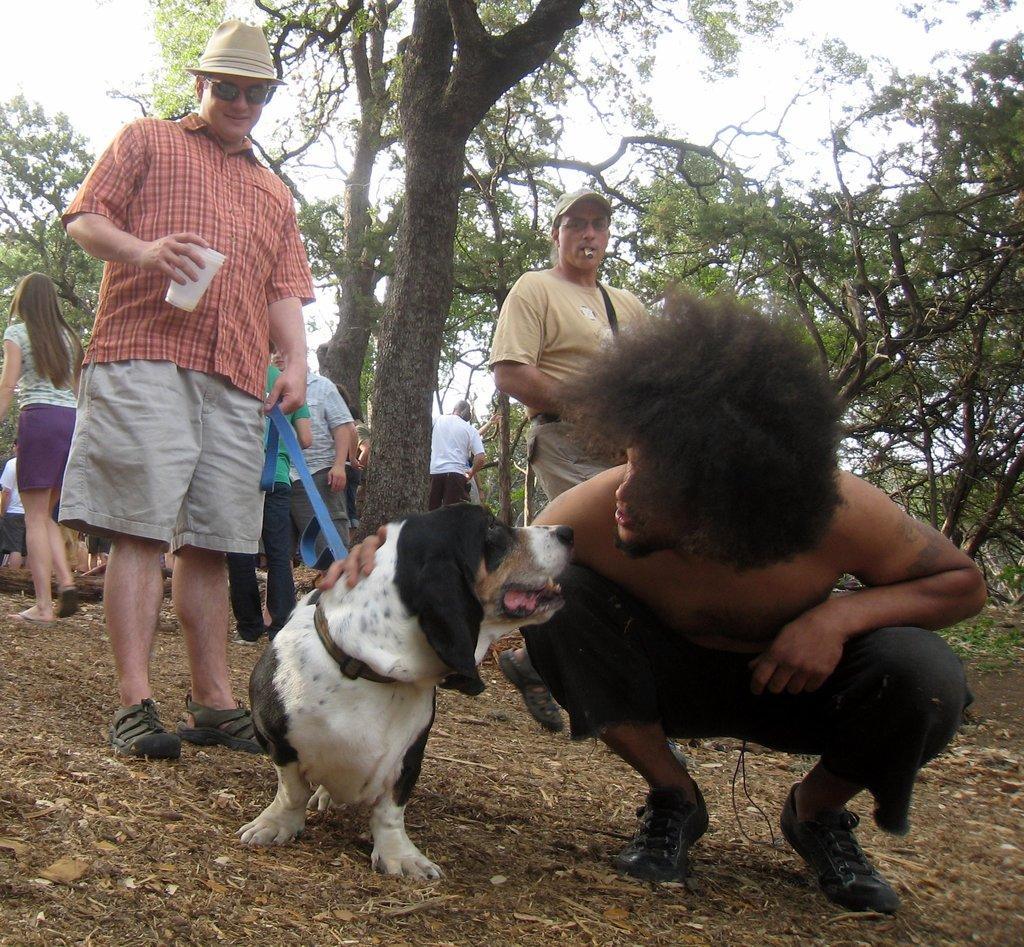Could you give a brief overview of what you see in this image? As we can see in the image there is a sky, tree, few people here and there and there is a dog. 